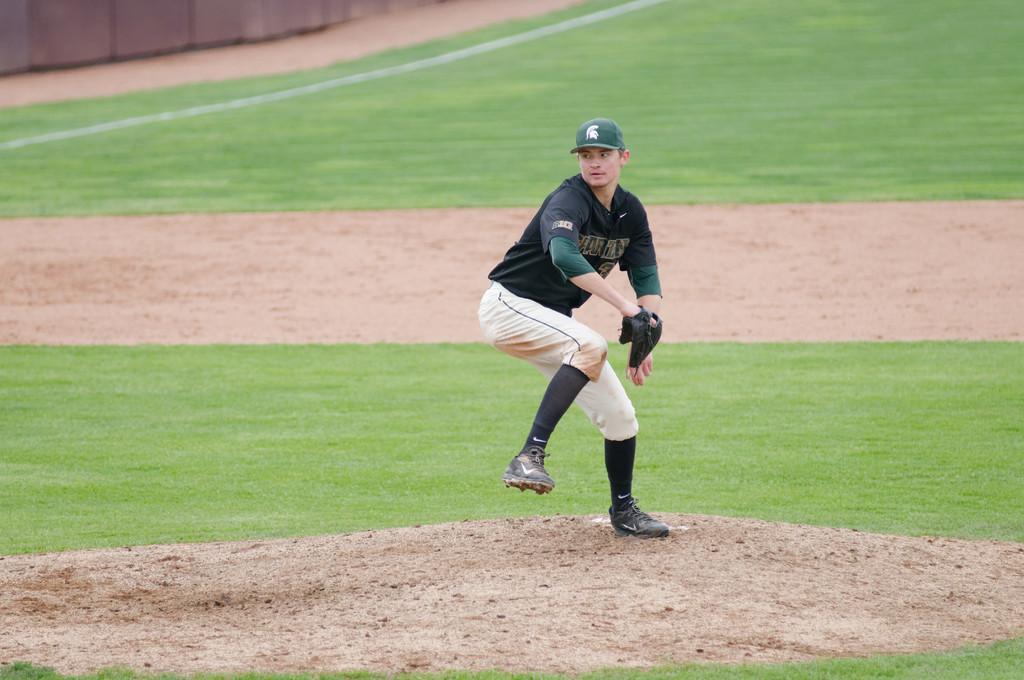Please provide a concise description of this image. In the center of the picture there is a person wearing glove and holding a ball, this is a baseball ground. In the picture there is soil and grass. 